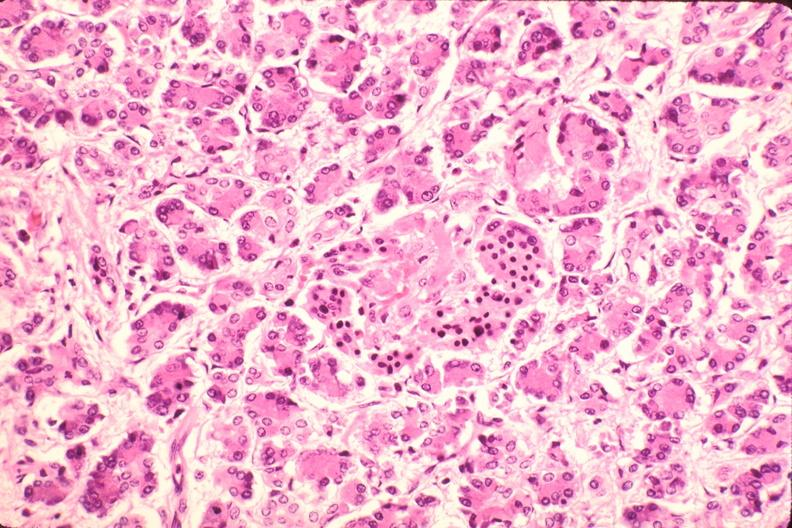s metastatic carcinoma prostate present?
Answer the question using a single word or phrase. No 